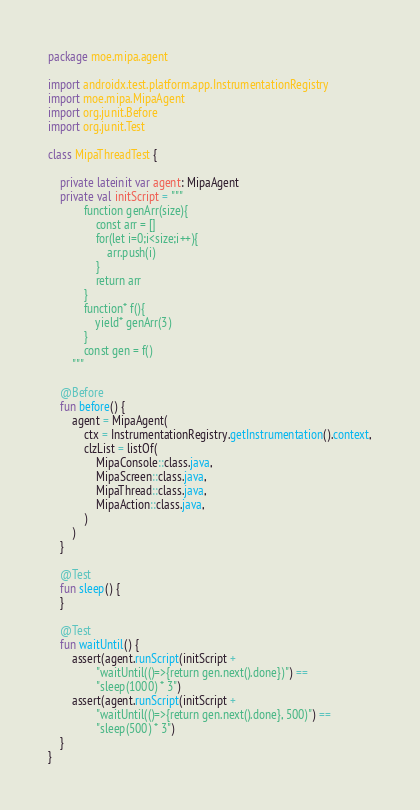<code> <loc_0><loc_0><loc_500><loc_500><_Kotlin_>package moe.mipa.agent

import androidx.test.platform.app.InstrumentationRegistry
import moe.mipa.MipaAgent
import org.junit.Before
import org.junit.Test

class MipaThreadTest {

    private lateinit var agent: MipaAgent
    private val initScript = """
            function genArr(size){
                const arr = []
                for(let i=0;i<size;i++){
                    arr.push(i)
                }
                return arr
            }
            function* f(){
                yield* genArr(3)
            }
            const gen = f()
        """

    @Before
    fun before() {
        agent = MipaAgent(
            ctx = InstrumentationRegistry.getInstrumentation().context,
            clzList = listOf(
                MipaConsole::class.java,
                MipaScreen::class.java,
                MipaThread::class.java,
                MipaAction::class.java,
            )
        )
    }

    @Test
    fun sleep() {
    }

    @Test
    fun waitUntil() {
        assert(agent.runScript(initScript +
                "waitUntil(()=>{return gen.next().done})") ==
                "sleep(1000) * 3")
        assert(agent.runScript(initScript +
                "waitUntil(()=>{return gen.next().done}, 500)") ==
                "sleep(500) * 3")
    }
}</code> 